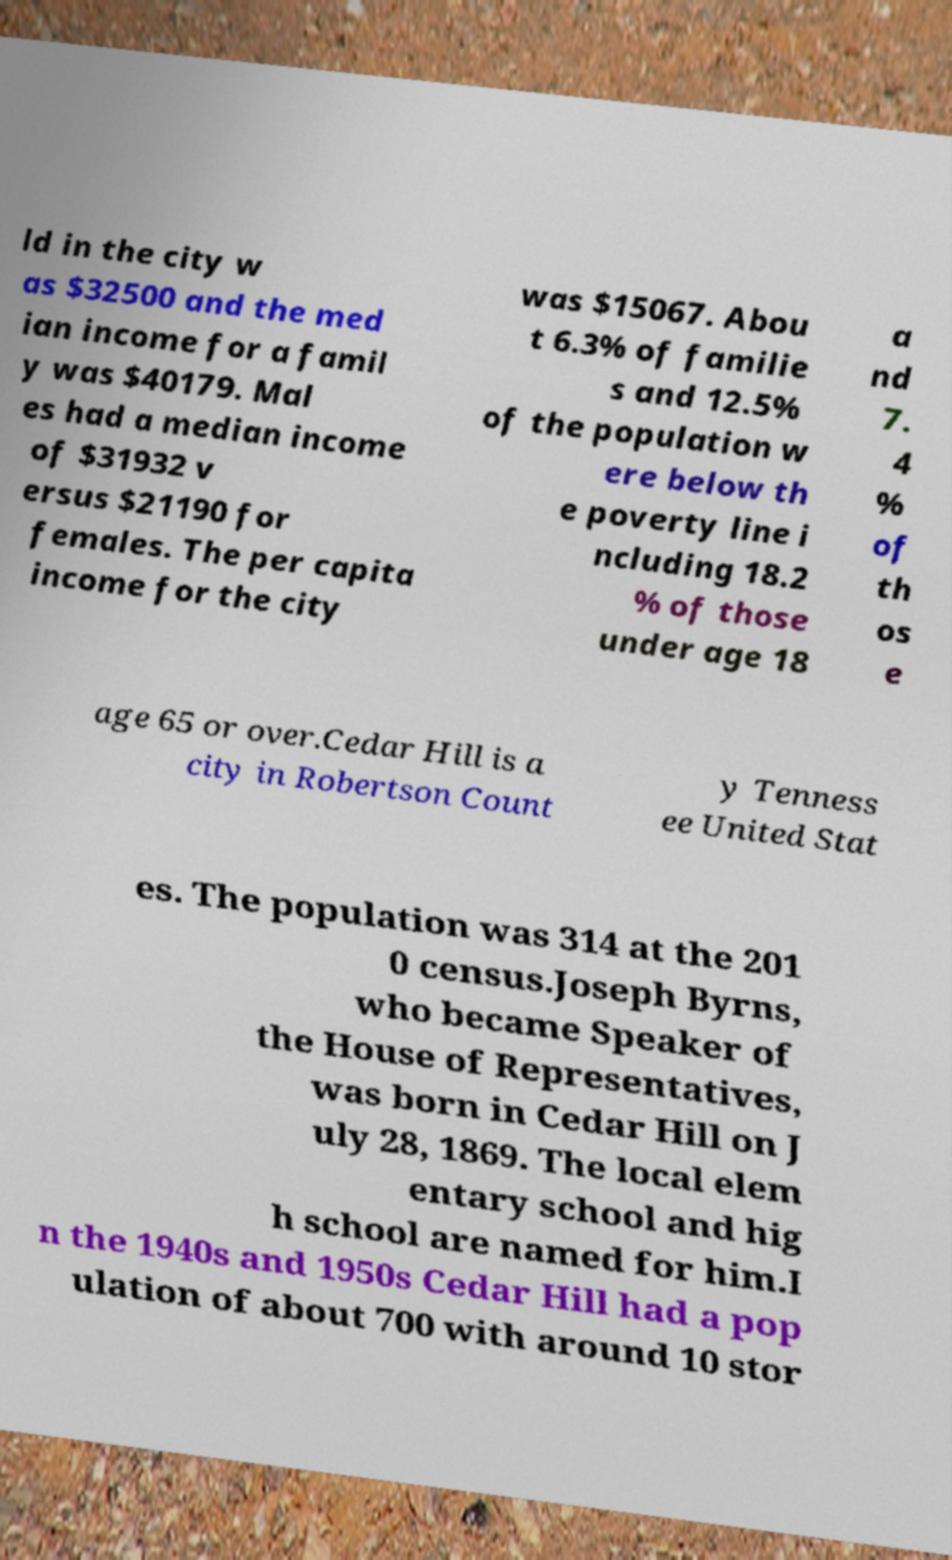Could you assist in decoding the text presented in this image and type it out clearly? ld in the city w as $32500 and the med ian income for a famil y was $40179. Mal es had a median income of $31932 v ersus $21190 for females. The per capita income for the city was $15067. Abou t 6.3% of familie s and 12.5% of the population w ere below th e poverty line i ncluding 18.2 % of those under age 18 a nd 7. 4 % of th os e age 65 or over.Cedar Hill is a city in Robertson Count y Tenness ee United Stat es. The population was 314 at the 201 0 census.Joseph Byrns, who became Speaker of the House of Representatives, was born in Cedar Hill on J uly 28, 1869. The local elem entary school and hig h school are named for him.I n the 1940s and 1950s Cedar Hill had a pop ulation of about 700 with around 10 stor 